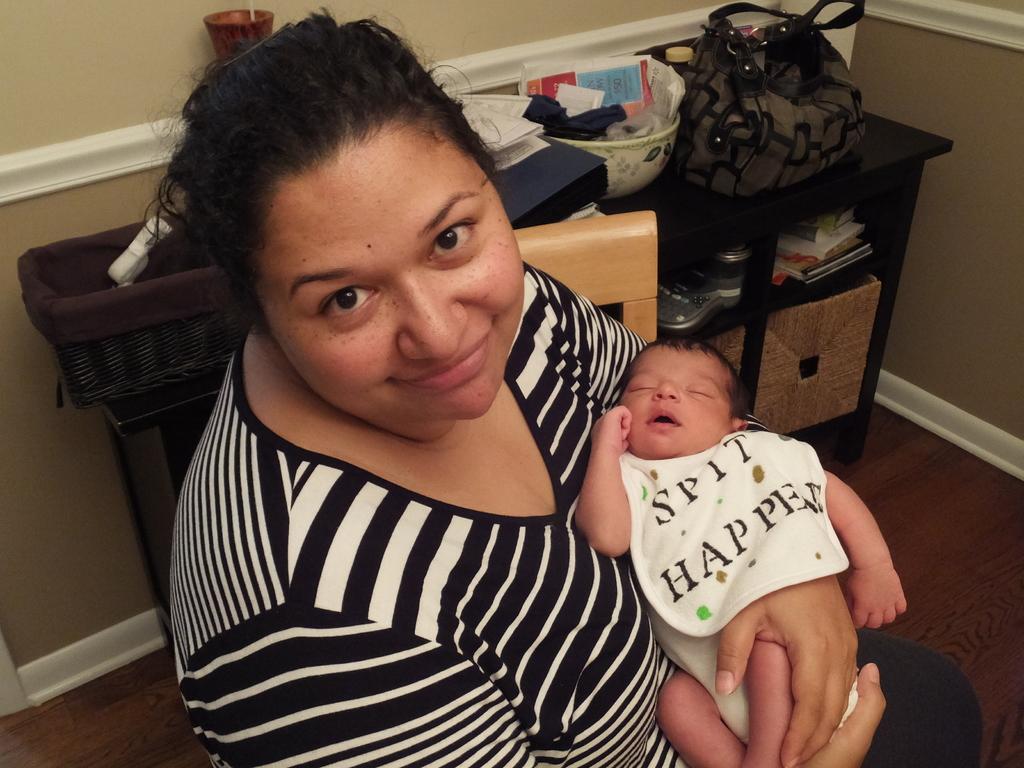In one or two sentences, can you explain what this image depicts? In this image I can see that two person among them one is a woman who is holding a baby in a hand and smiling, behind the woman we have a table, a bag and few other stuff. The woman is sitting on the chair. 